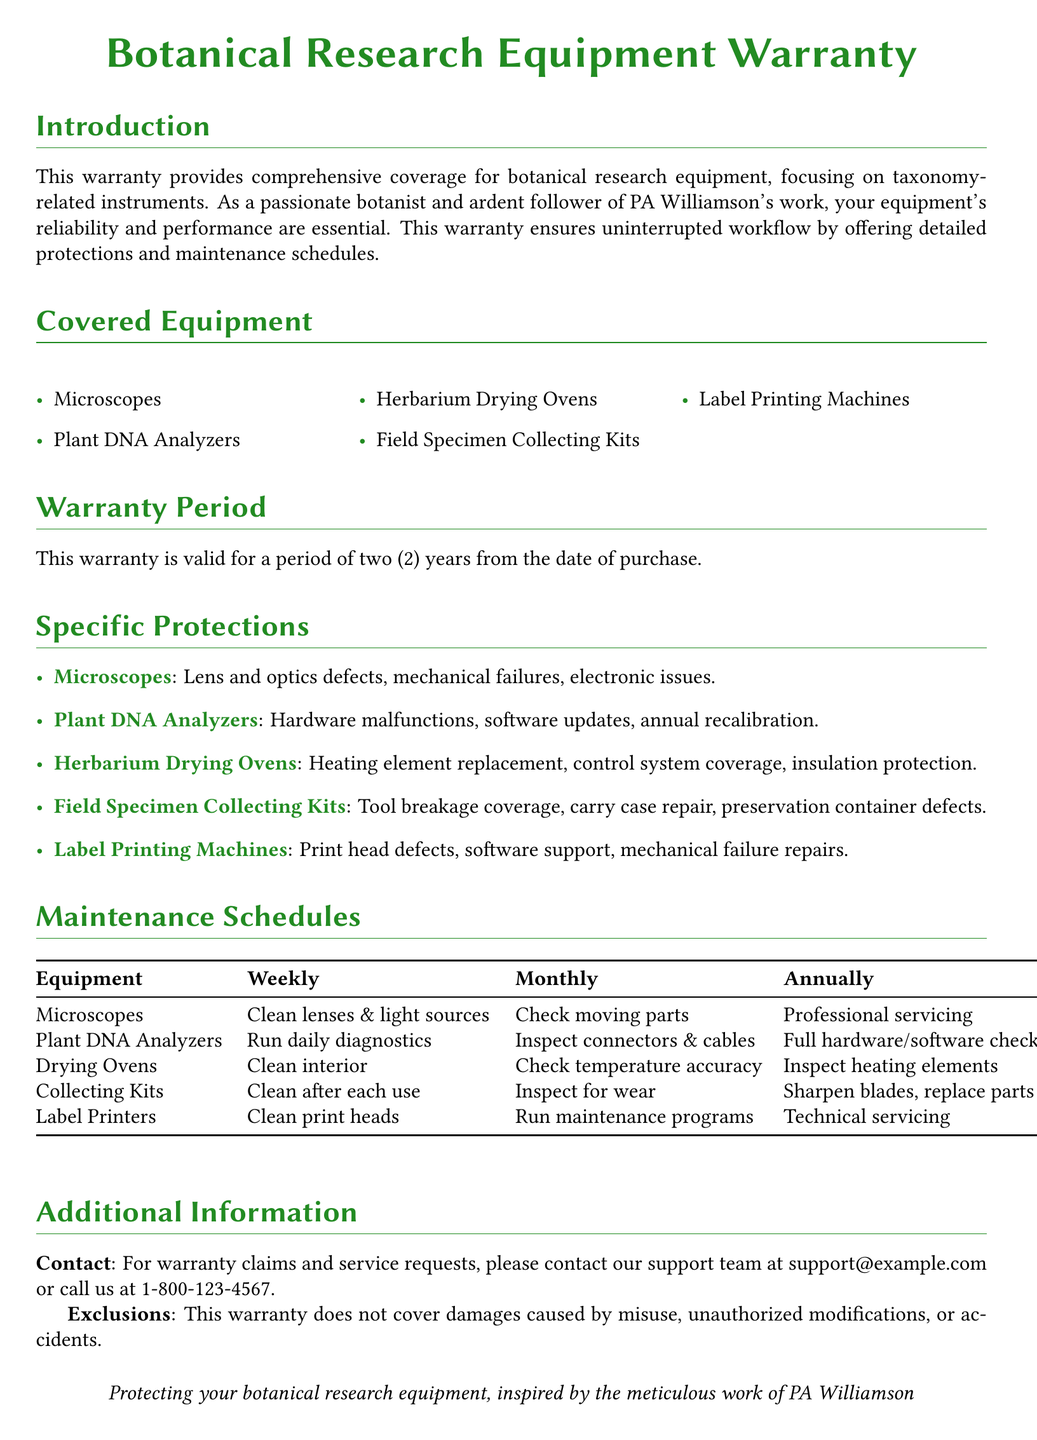what is the warranty period for the equipment? The warranty is valid for a period of two (2) years from the date of purchase.
Answer: two (2) years which equipment covers heating element replacement? This is specified under the specific protections for herbarium drying ovens.
Answer: Herbarium Drying Ovens what maintenance task is required weekly for Plant DNA Analyzers? The document states that weekly maintenance involves running daily diagnostics.
Answer: Run daily diagnostics how often should microscopes undergo professional servicing? According to the maintenance schedule, professional servicing is required annually.
Answer: Annually what is excluded from the warranty coverage? The warranty does not cover damages caused by misuse, unauthorized modifications, or accidents.
Answer: Misuse, unauthorized modifications, or accidents which equipment requires sharpening of blades? This requirement is listed under the maintenance schedule for field specimen collecting kits.
Answer: Field Specimen Collecting Kits how can you contact support for warranty claims? The document lists support contact information, including email and phone number.
Answer: support@example.com or call us at 1-800-123-4567 which equipment has coverage for tool breakage? This information is included under the specific protections for collecting kits.
Answer: Field Specimen Collecting Kits 